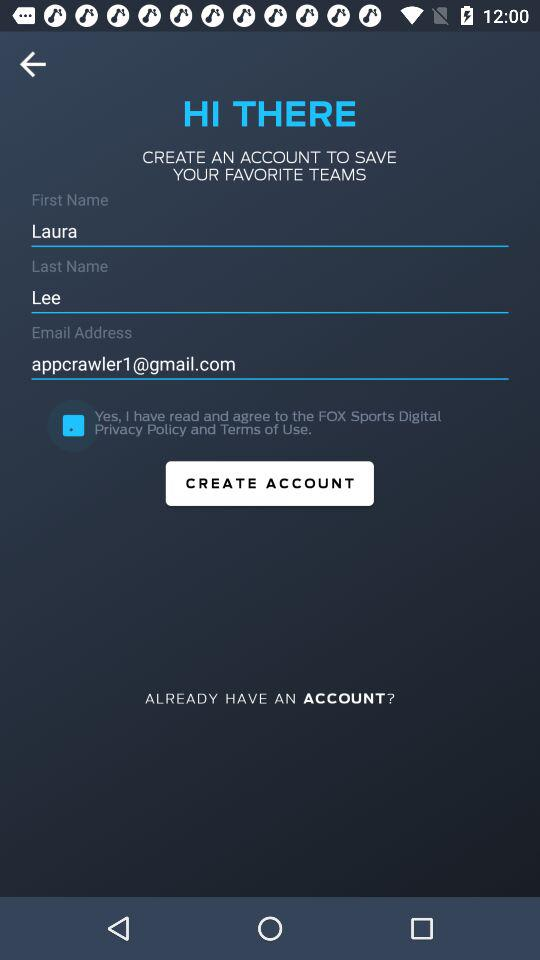What is the first name? The first name is Laura. 